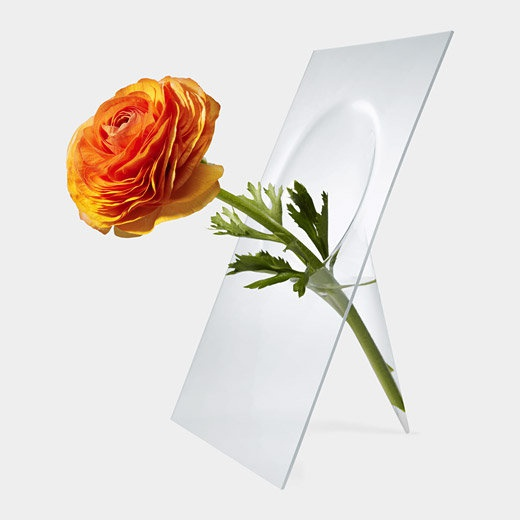Describe the objects in this image and their specific colors. I can see a vase in white, lightgray, darkgreen, darkgray, and olive tones in this image. 